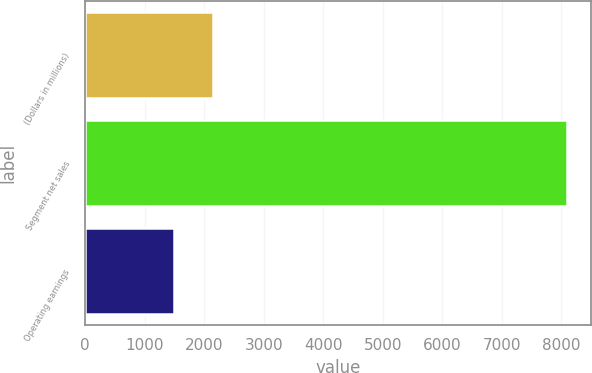<chart> <loc_0><loc_0><loc_500><loc_500><bar_chart><fcel>(Dollars in millions)<fcel>Segment net sales<fcel>Operating earnings<nl><fcel>2155.7<fcel>8093<fcel>1496<nl></chart> 